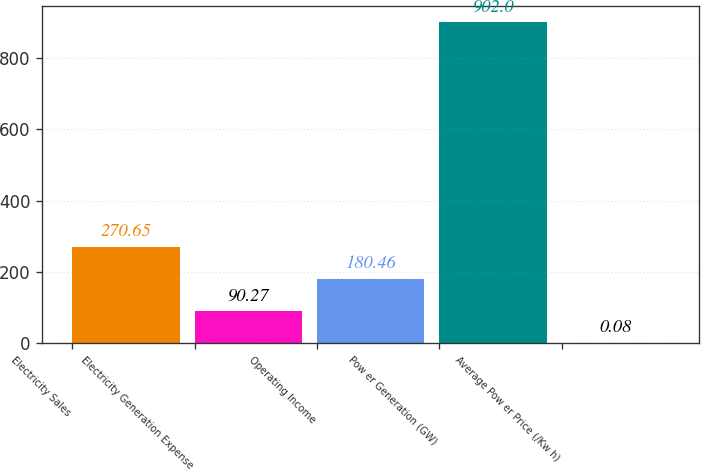<chart> <loc_0><loc_0><loc_500><loc_500><bar_chart><fcel>Electricity Sales<fcel>Electricity Generation Expense<fcel>Operating Income<fcel>Pow er Generation (GW)<fcel>Average Pow er Price (/Kw h)<nl><fcel>270.65<fcel>90.27<fcel>180.46<fcel>902<fcel>0.08<nl></chart> 